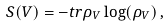<formula> <loc_0><loc_0><loc_500><loc_500>S ( V ) = - t r \rho _ { V } \log ( \rho _ { V } ) \, ,</formula> 